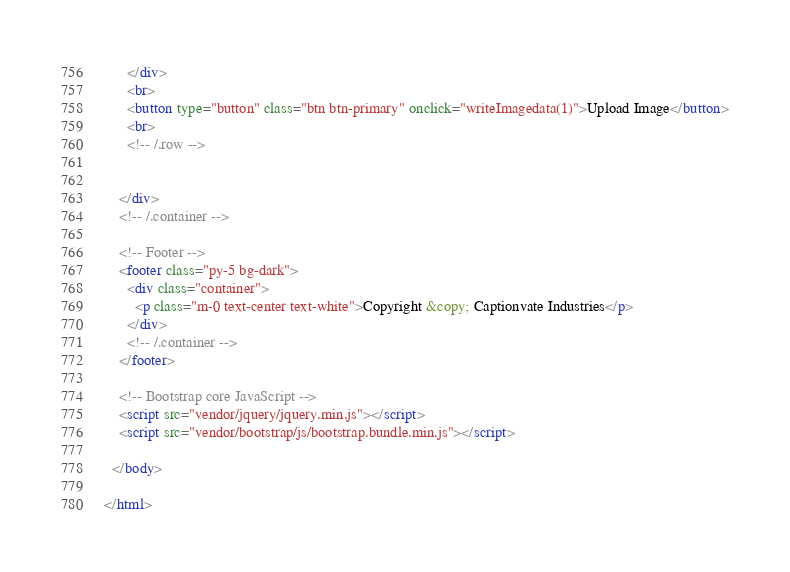<code> <loc_0><loc_0><loc_500><loc_500><_HTML_>      </div>
      <br>
      <button type="button" class="btn btn-primary" onclick="writeImagedata(1)">Upload Image</button>
      <br>
      <!-- /.row -->


    </div>
    <!-- /.container -->

    <!-- Footer -->
    <footer class="py-5 bg-dark">
      <div class="container">
        <p class="m-0 text-center text-white">Copyright &copy; Captionvate Industries</p>
      </div>
      <!-- /.container -->
    </footer>

    <!-- Bootstrap core JavaScript -->
    <script src="vendor/jquery/jquery.min.js"></script>
    <script src="vendor/bootstrap/js/bootstrap.bundle.min.js"></script>

  </body>

</html>
</code> 